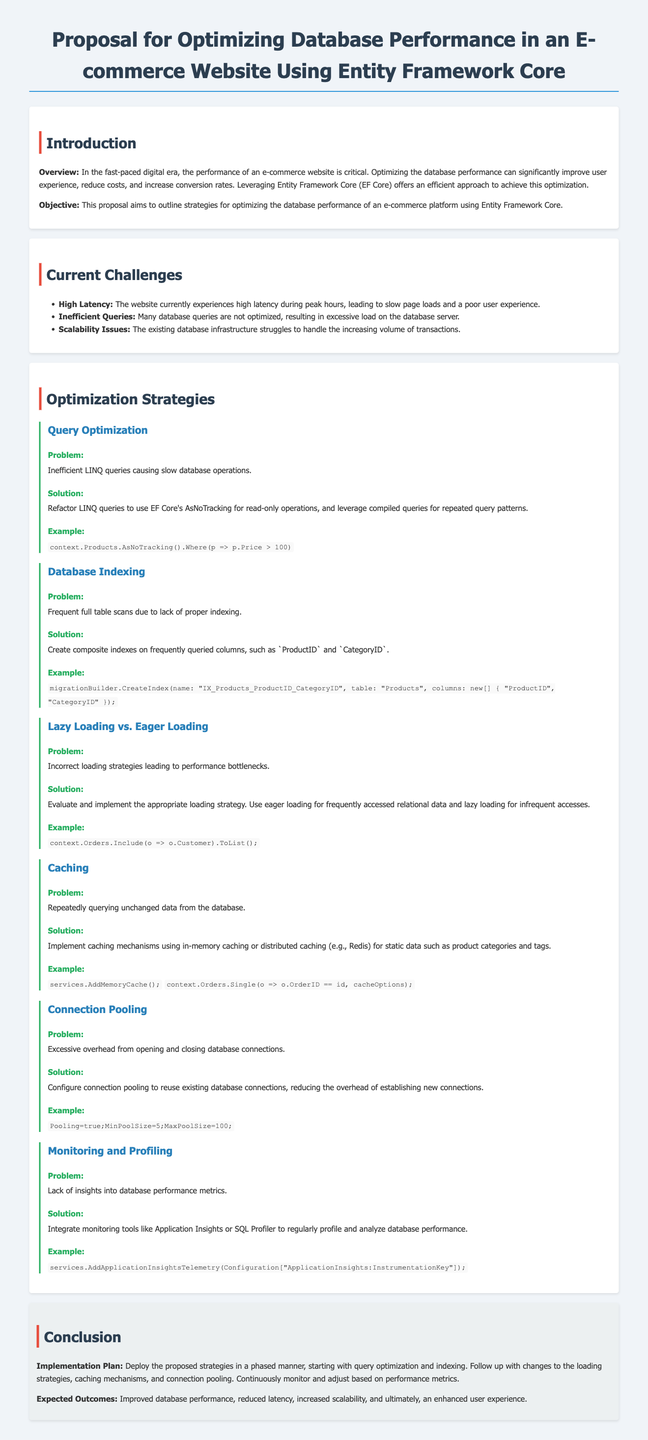What is the main objective of the proposal? The objective is outlined in the proposal as the strategies for optimizing database performance using Entity Framework Core.
Answer: Optimize database performance What is one of the current challenges faced by the e-commerce website? The document lists several challenges, one being high latency during peak hours.
Answer: High latency Which solution is proposed for inefficient LINQ queries? The proposal suggests refactoring LINQ queries to use EF Core's AsNoTracking for read-only operations.
Answer: Refactor LINQ queries What type of caching mechanism is recommended in the proposal? The document mentions implementing in-memory caching or distributed caching like Redis for static data.
Answer: In-memory caching What tool is suggested for monitoring database performance? The proposal recommends integrating monitoring tools like Application Insights or SQL Profiler.
Answer: Application Insights What specific example is given for Lazy Loading? The example given in the document shows using Include for eager loading with orders and customers.
Answer: context.Orders.Include(o => o.Customer).ToList() What are the expected outcomes of the proposed strategies? The expected outcomes listed include improved database performance and reduced latency.
Answer: Improved database performance Which two aspects are combined in composite indexes according to the proposal? The proposal specifies creating composite indexes on frequently queried columns like ProductID and CategoryID.
Answer: ProductID and CategoryID What is the implementation plan's starting focus? The implementation plan suggests starting with query optimization and indexing.
Answer: Query optimization and indexing 